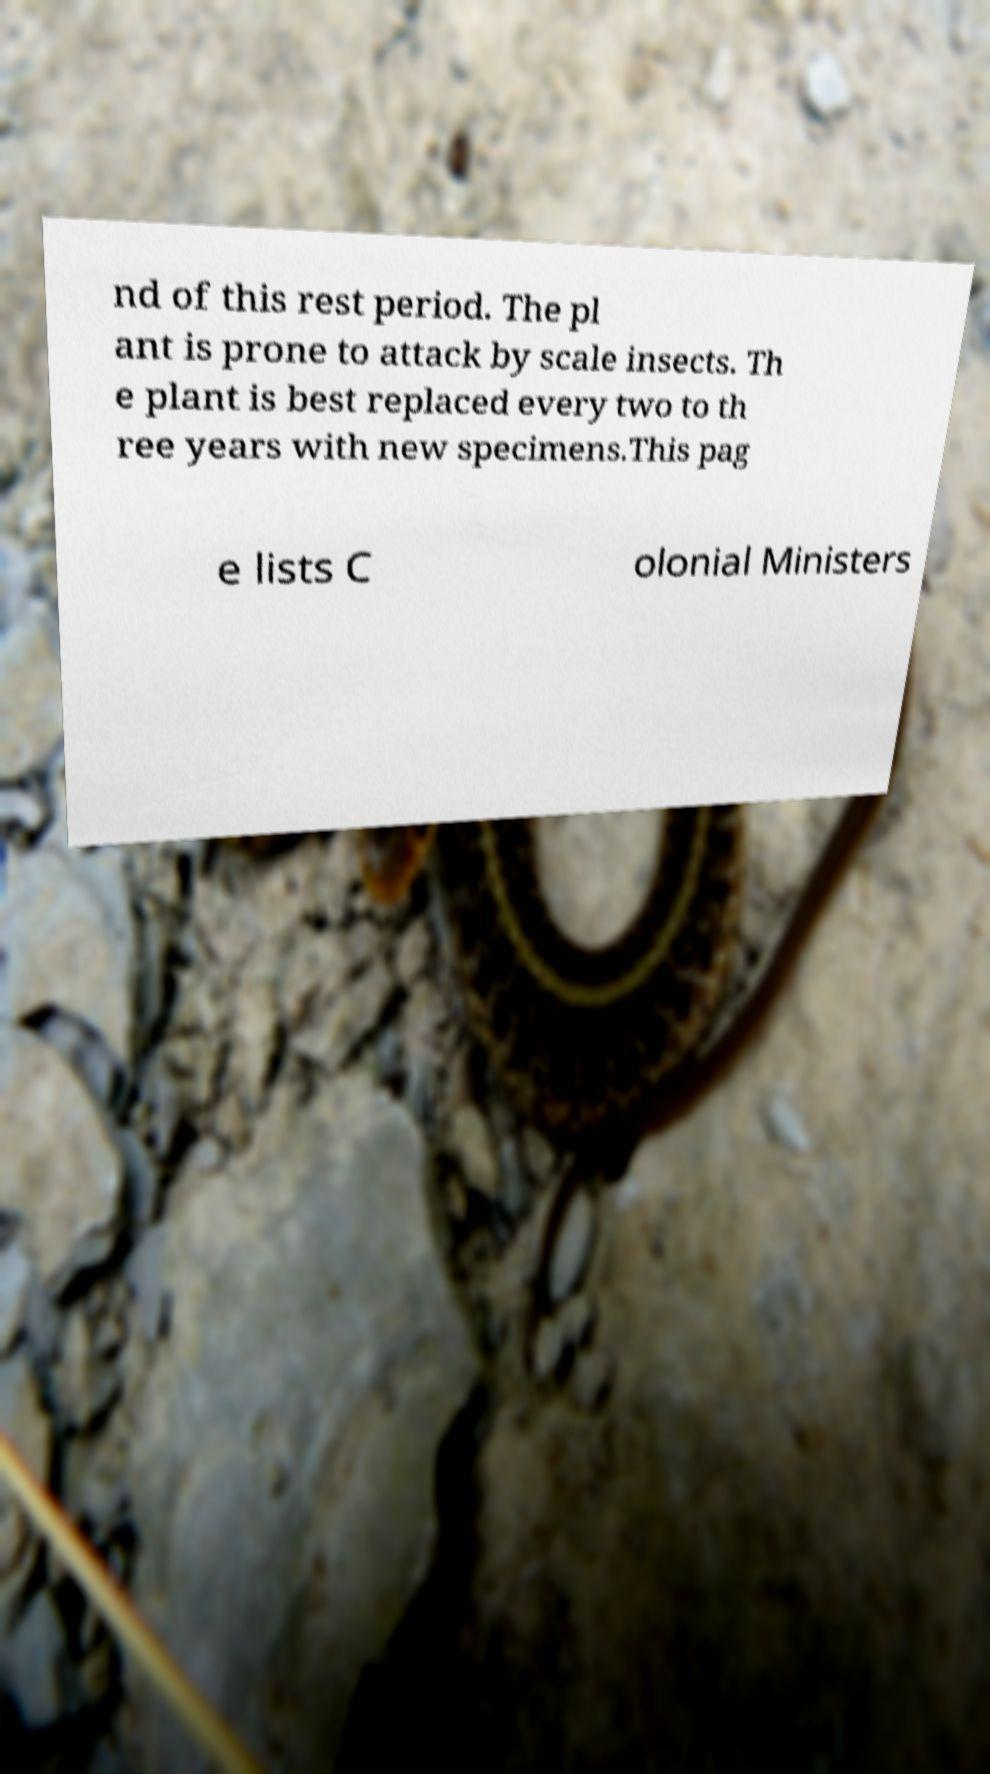Can you read and provide the text displayed in the image?This photo seems to have some interesting text. Can you extract and type it out for me? nd of this rest period. The pl ant is prone to attack by scale insects. Th e plant is best replaced every two to th ree years with new specimens.This pag e lists C olonial Ministers 